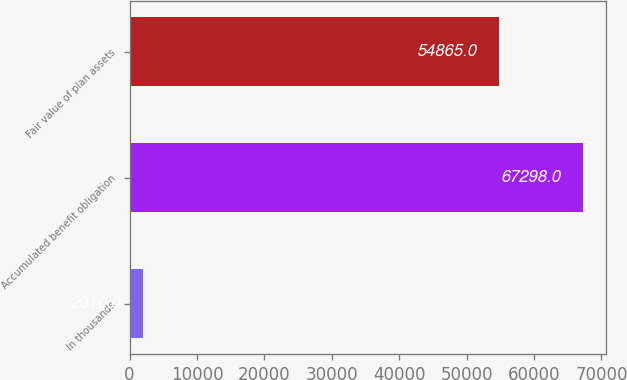<chart> <loc_0><loc_0><loc_500><loc_500><bar_chart><fcel>In thousands<fcel>Accumulated benefit obligation<fcel>Fair value of plan assets<nl><fcel>2010<fcel>67298<fcel>54865<nl></chart> 